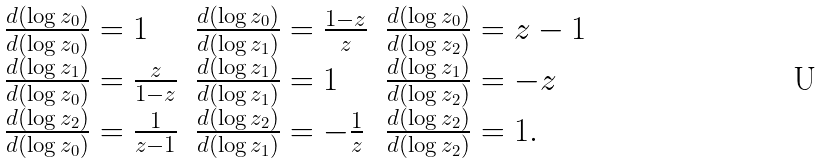Convert formula to latex. <formula><loc_0><loc_0><loc_500><loc_500>\begin{array} { l l l } \frac { d ( \log z _ { 0 } ) } { d ( \log z _ { 0 } ) } = 1 & \frac { d ( \log z _ { 0 } ) } { d ( \log z _ { 1 } ) } = \frac { 1 - z } { z } & \frac { d ( \log z _ { 0 } ) } { d ( \log z _ { 2 } ) } = z - 1 \\ \frac { d ( \log z _ { 1 } ) } { d ( \log z _ { 0 } ) } = \frac { z } { 1 - z } & \frac { d ( \log z _ { 1 } ) } { d ( \log z _ { 1 } ) } = 1 & \frac { d ( \log z _ { 1 } ) } { d ( \log z _ { 2 } ) } = - z \\ \frac { d ( \log z _ { 2 } ) } { d ( \log z _ { 0 } ) } = \frac { 1 } { z - 1 } & \frac { d ( \log z _ { 2 } ) } { d ( \log z _ { 1 } ) } = - \frac { 1 } { z } & \frac { d ( \log z _ { 2 } ) } { d ( \log z _ { 2 } ) } = 1 . \\ \end{array}</formula> 